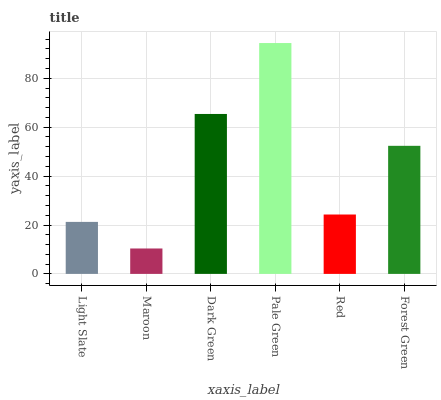Is Maroon the minimum?
Answer yes or no. Yes. Is Pale Green the maximum?
Answer yes or no. Yes. Is Dark Green the minimum?
Answer yes or no. No. Is Dark Green the maximum?
Answer yes or no. No. Is Dark Green greater than Maroon?
Answer yes or no. Yes. Is Maroon less than Dark Green?
Answer yes or no. Yes. Is Maroon greater than Dark Green?
Answer yes or no. No. Is Dark Green less than Maroon?
Answer yes or no. No. Is Forest Green the high median?
Answer yes or no. Yes. Is Red the low median?
Answer yes or no. Yes. Is Dark Green the high median?
Answer yes or no. No. Is Pale Green the low median?
Answer yes or no. No. 